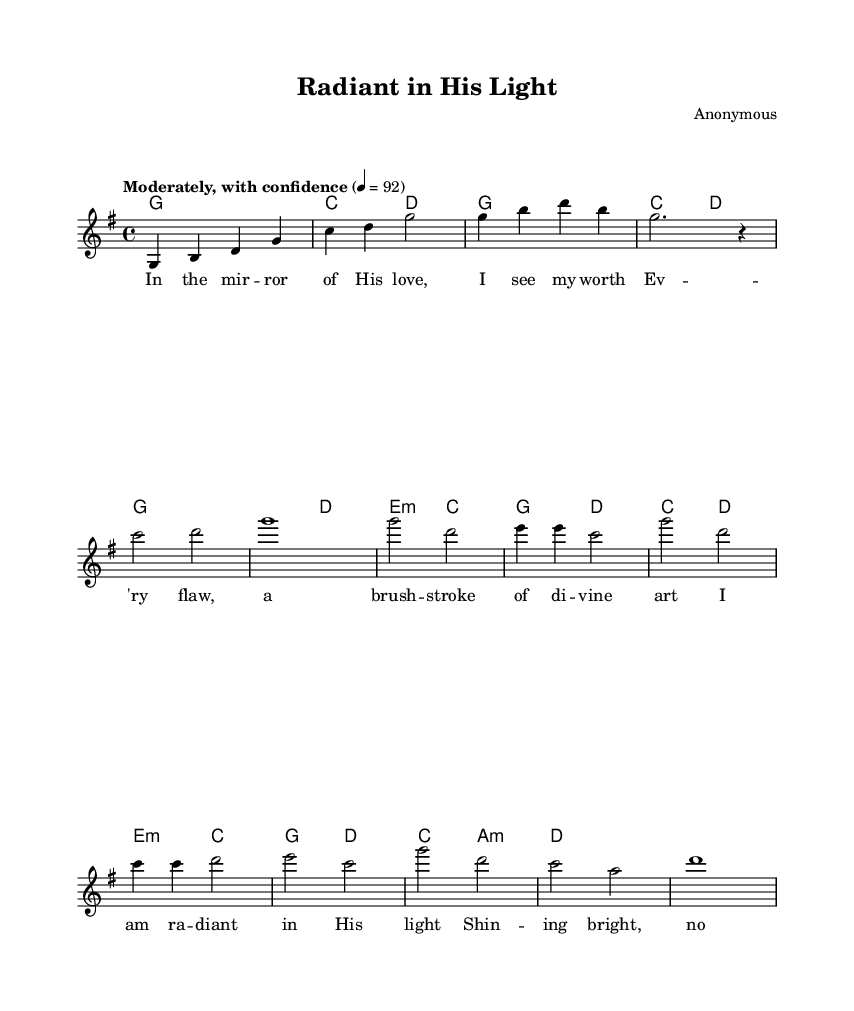What is the key signature of this music? The key signature is G major, which has one sharp (F#). This can be determined by looking at the presence of the G major key indicated at the beginning of the sheet music.
Answer: G major What is the time signature of the piece? The time signature is 4/4, as shown at the beginning of the score. This indicates there are four beats in each measure, and a quarter note gets one beat.
Answer: 4/4 What is the tempo marking for this piece? The tempo marking is "Moderately, with confidence", indicated in the score along with the metronome marking of 92 beats per minute.
Answer: Moderately, with confidence How many measures are there in the chorus section? The chorus consists of four measures. By counting the measures from the score after the verse, we confirm that there are four distinct measure lines representing the chorus.
Answer: Four What kind of message does the title "Radiant in His Light" convey? The title suggests a positive self-image and confidence under divine love, which aligns with the themes of self-esteem and spiritual encouragement often found in modern hymns.
Answer: Positive self-image Which lyrics express the idea of worth? The lyrics "In the mirror of His love, I see my worth" directly state the concept of self-worth, reflecting the overall uplifting message of the piece.
Answer: I see my worth What is the climax or peak of the melody during the chorus? The climax occurs on the notes during "I am radiant in His light", where the melody likely ascends to its highest pitch, emphasizing the positive affirmation. This can be determined by analyzing the melody line and noting the highest notes during the chorus section.
Answer: The highest pitch of "I am radiant in His light" 